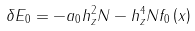Convert formula to latex. <formula><loc_0><loc_0><loc_500><loc_500>\delta E _ { 0 } = - a _ { 0 } h _ { z } ^ { 2 } N - h _ { z } ^ { 4 } N f _ { 0 } \left ( x \right )</formula> 